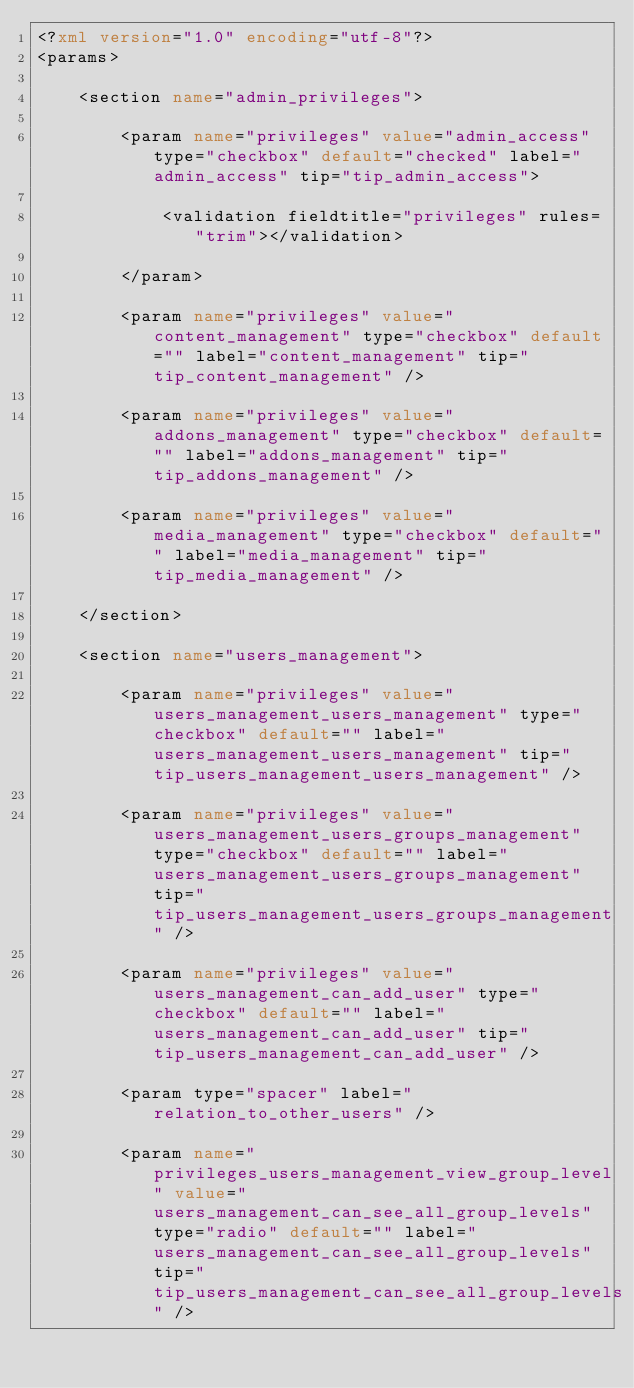Convert code to text. <code><loc_0><loc_0><loc_500><loc_500><_XML_><?xml version="1.0" encoding="utf-8"?>
<params>
	
	<section name="admin_privileges">
		
		<param name="privileges" value="admin_access" type="checkbox" default="checked" label="admin_access" tip="tip_admin_access">
			
			<validation fieldtitle="privileges" rules="trim"></validation>
			
		</param>
		
		<param name="privileges" value="content_management" type="checkbox" default="" label="content_management" tip="tip_content_management" />
		
		<param name="privileges" value="addons_management" type="checkbox" default="" label="addons_management" tip="tip_addons_management" />
		
		<param name="privileges" value="media_management" type="checkbox" default="" label="media_management" tip="tip_media_management" />
		
	</section>
	
	<section name="users_management">
		
		<param name="privileges" value="users_management_users_management" type="checkbox" default="" label="users_management_users_management" tip="tip_users_management_users_management" />
		
		<param name="privileges" value="users_management_users_groups_management" type="checkbox" default="" label="users_management_users_groups_management" tip="tip_users_management_users_groups_management" />
		
		<param name="privileges" value="users_management_can_add_user" type="checkbox" default="" label="users_management_can_add_user" tip="tip_users_management_can_add_user" />
		
		<param type="spacer" label="relation_to_other_users" />
		
		<param name="privileges_users_management_view_group_level" value="users_management_can_see_all_group_levels" type="radio" default="" label="users_management_can_see_all_group_levels" tip="tip_users_management_can_see_all_group_levels" /></code> 